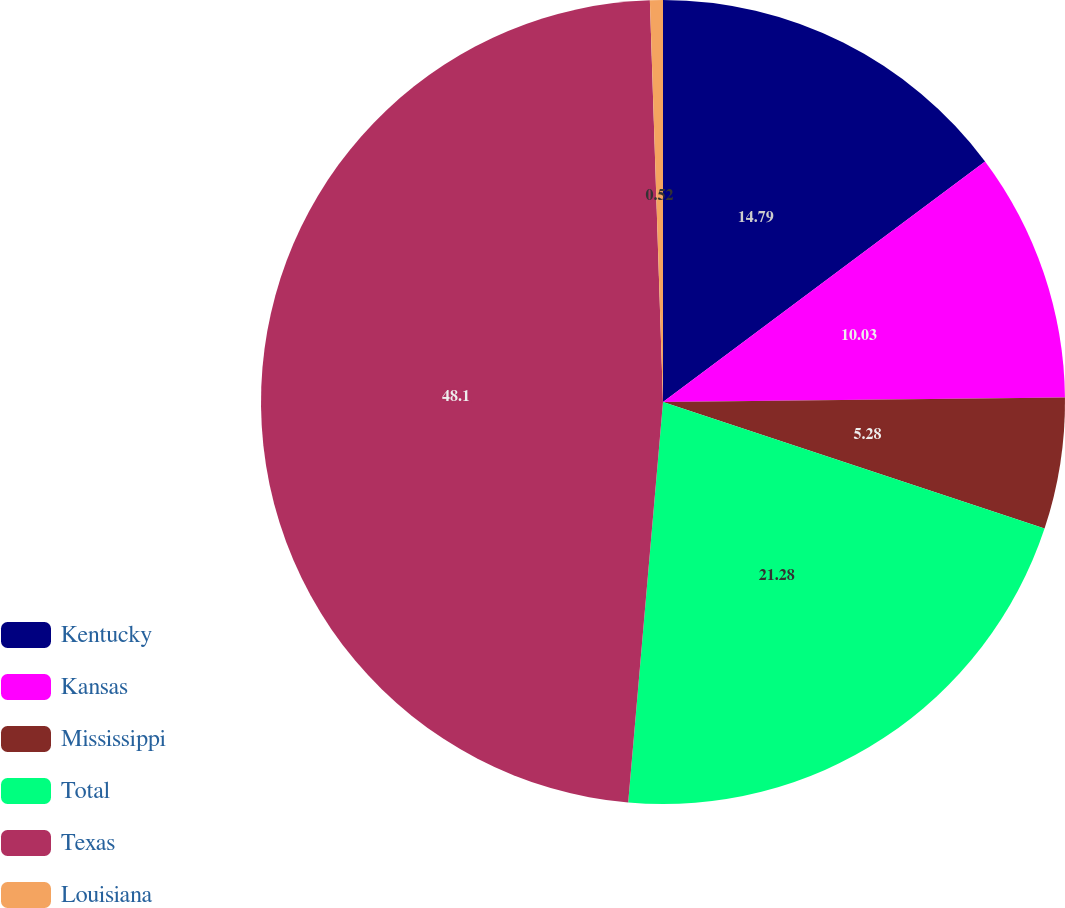Convert chart. <chart><loc_0><loc_0><loc_500><loc_500><pie_chart><fcel>Kentucky<fcel>Kansas<fcel>Mississippi<fcel>Total<fcel>Texas<fcel>Louisiana<nl><fcel>14.79%<fcel>10.03%<fcel>5.28%<fcel>21.28%<fcel>48.1%<fcel>0.52%<nl></chart> 